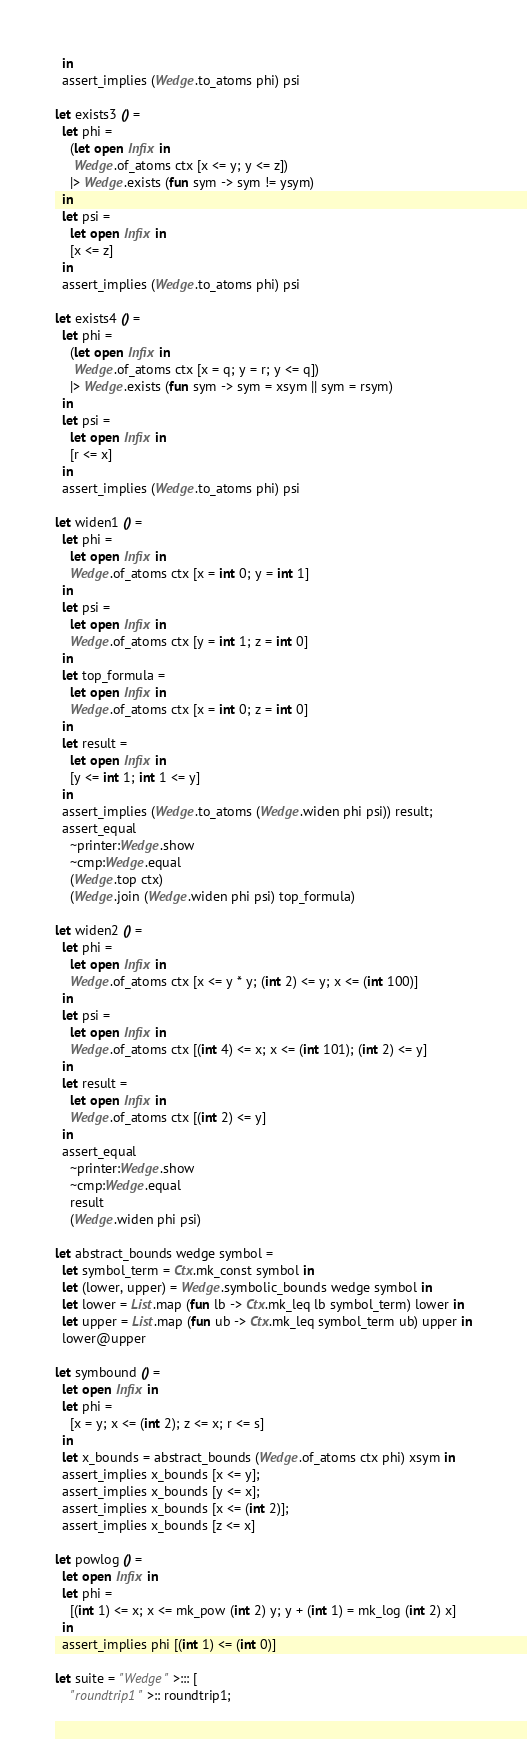Convert code to text. <code><loc_0><loc_0><loc_500><loc_500><_OCaml_>  in
  assert_implies (Wedge.to_atoms phi) psi

let exists3 () =
  let phi =
    (let open Infix in
     Wedge.of_atoms ctx [x <= y; y <= z])
    |> Wedge.exists (fun sym -> sym != ysym)
  in
  let psi =
    let open Infix in
    [x <= z]
  in
  assert_implies (Wedge.to_atoms phi) psi

let exists4 () =
  let phi =
    (let open Infix in
     Wedge.of_atoms ctx [x = q; y = r; y <= q])
    |> Wedge.exists (fun sym -> sym = xsym || sym = rsym)
  in
  let psi =
    let open Infix in
    [r <= x]
  in
  assert_implies (Wedge.to_atoms phi) psi

let widen1 () =
  let phi =
    let open Infix in
    Wedge.of_atoms ctx [x = int 0; y = int 1]
  in
  let psi =
    let open Infix in
    Wedge.of_atoms ctx [y = int 1; z = int 0]
  in
  let top_formula =
    let open Infix in
    Wedge.of_atoms ctx [x = int 0; z = int 0]
  in
  let result =
    let open Infix in
    [y <= int 1; int 1 <= y]
  in
  assert_implies (Wedge.to_atoms (Wedge.widen phi psi)) result;
  assert_equal
    ~printer:Wedge.show
    ~cmp:Wedge.equal
    (Wedge.top ctx)
    (Wedge.join (Wedge.widen phi psi) top_formula)

let widen2 () =
  let phi =
    let open Infix in
    Wedge.of_atoms ctx [x <= y * y; (int 2) <= y; x <= (int 100)]
  in
  let psi =
    let open Infix in
    Wedge.of_atoms ctx [(int 4) <= x; x <= (int 101); (int 2) <= y]
  in
  let result =
    let open Infix in
    Wedge.of_atoms ctx [(int 2) <= y]
  in
  assert_equal
    ~printer:Wedge.show
    ~cmp:Wedge.equal
    result
    (Wedge.widen phi psi)

let abstract_bounds wedge symbol =
  let symbol_term = Ctx.mk_const symbol in
  let (lower, upper) = Wedge.symbolic_bounds wedge symbol in
  let lower = List.map (fun lb -> Ctx.mk_leq lb symbol_term) lower in
  let upper = List.map (fun ub -> Ctx.mk_leq symbol_term ub) upper in
  lower@upper

let symbound () =
  let open Infix in
  let phi =
    [x = y; x <= (int 2); z <= x; r <= s]
  in
  let x_bounds = abstract_bounds (Wedge.of_atoms ctx phi) xsym in
  assert_implies x_bounds [x <= y];
  assert_implies x_bounds [y <= x];
  assert_implies x_bounds [x <= (int 2)];
  assert_implies x_bounds [z <= x]

let powlog () =
  let open Infix in
  let phi =
    [(int 1) <= x; x <= mk_pow (int 2) y; y + (int 1) = mk_log (int 2) x]
  in
  assert_implies phi [(int 1) <= (int 0)]

let suite = "Wedge" >::: [
    "roundtrip1" >:: roundtrip1;</code> 